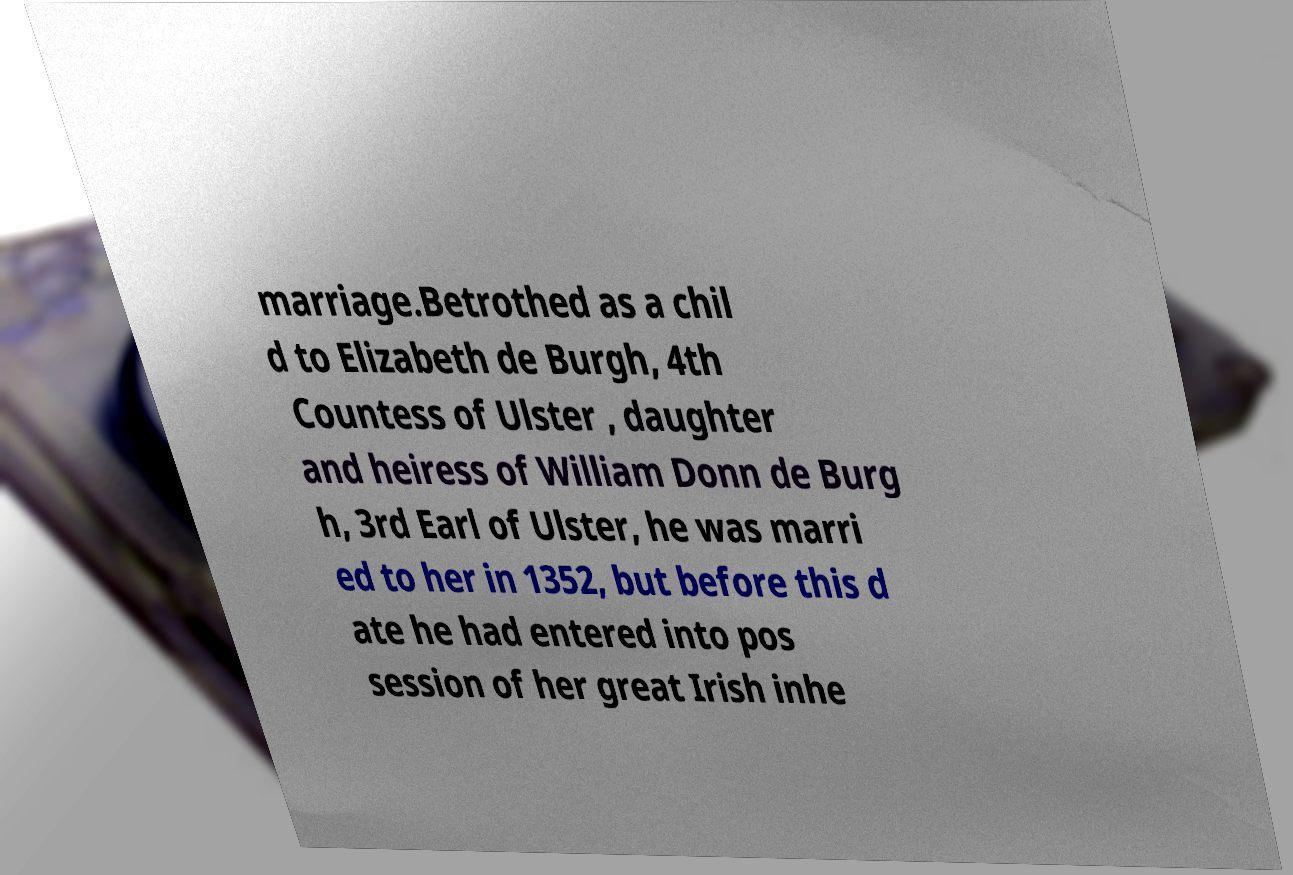Please read and relay the text visible in this image. What does it say? marriage.Betrothed as a chil d to Elizabeth de Burgh, 4th Countess of Ulster , daughter and heiress of William Donn de Burg h, 3rd Earl of Ulster, he was marri ed to her in 1352, but before this d ate he had entered into pos session of her great Irish inhe 